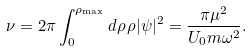Convert formula to latex. <formula><loc_0><loc_0><loc_500><loc_500>\nu = 2 \pi \int _ { 0 } ^ { \rho _ { \mathrm \max } } d \rho \, \rho | \psi | ^ { 2 } = \frac { \pi \mu ^ { 2 } } { U _ { 0 } m \omega ^ { 2 } } .</formula> 